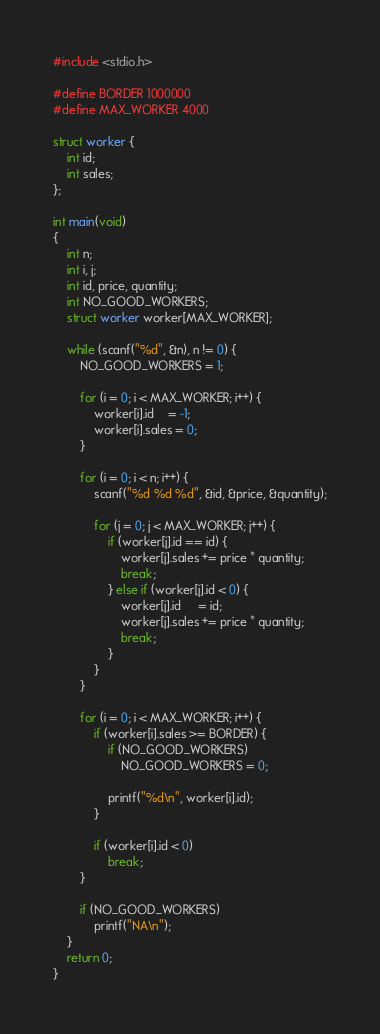<code> <loc_0><loc_0><loc_500><loc_500><_C_>#include <stdio.h>

#define BORDER 1000000
#define MAX_WORKER 4000

struct worker {
	int id;
	int sales;
};

int main(void) 
{
	int n;
	int i, j;
	int id, price, quantity;
	int NO_GOOD_WORKERS;
	struct worker worker[MAX_WORKER];

	while (scanf("%d", &n), n != 0) {
		NO_GOOD_WORKERS = 1;

		for (i = 0; i < MAX_WORKER; i++) {
			worker[i].id	= -1;
			worker[i].sales = 0;
		}

		for (i = 0; i < n; i++) {
			scanf("%d %d %d", &id, &price, &quantity);

			for (j = 0; j < MAX_WORKER; j++) {
				if (worker[j].id == id) {
					worker[j].sales += price * quantity;
					break;
				} else if (worker[j].id < 0) {
					worker[j].id	 = id;
					worker[j].sales += price * quantity;
					break;
				}
			}
		}
		
		for (i = 0; i < MAX_WORKER; i++) {
			if (worker[i].sales >= BORDER) {
				if (NO_GOOD_WORKERS) 
					NO_GOOD_WORKERS = 0;

				printf("%d\n", worker[i].id);
			}

			if (worker[i].id < 0) 
				break;
		}

		if (NO_GOOD_WORKERS) 
			printf("NA\n");
	}
	return 0;
}</code> 